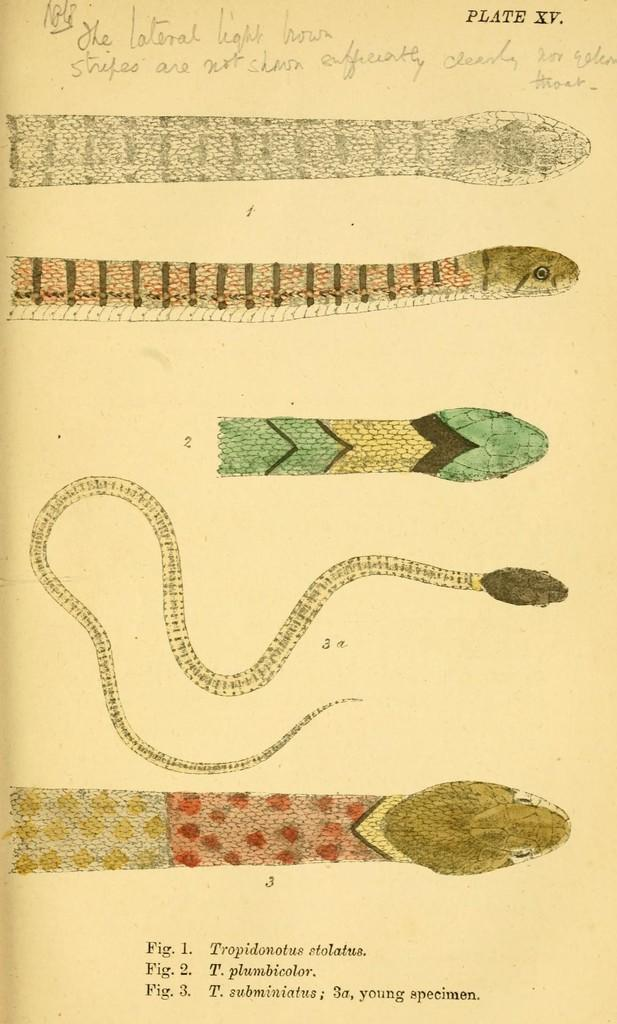What is present in the image that is made of paper? There is a paper in the image. What type of images can be seen on the paper? The paper contains images of snakes. Is there any text on the paper? Yes, there is text on the paper. What type of cake is being served to the dad in the image? There is no cake or dad present in the image; it only contains a paper with images of snakes and text. 